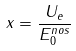<formula> <loc_0><loc_0><loc_500><loc_500>x = \frac { U _ { e } } { E _ { 0 } ^ { n o s } }</formula> 